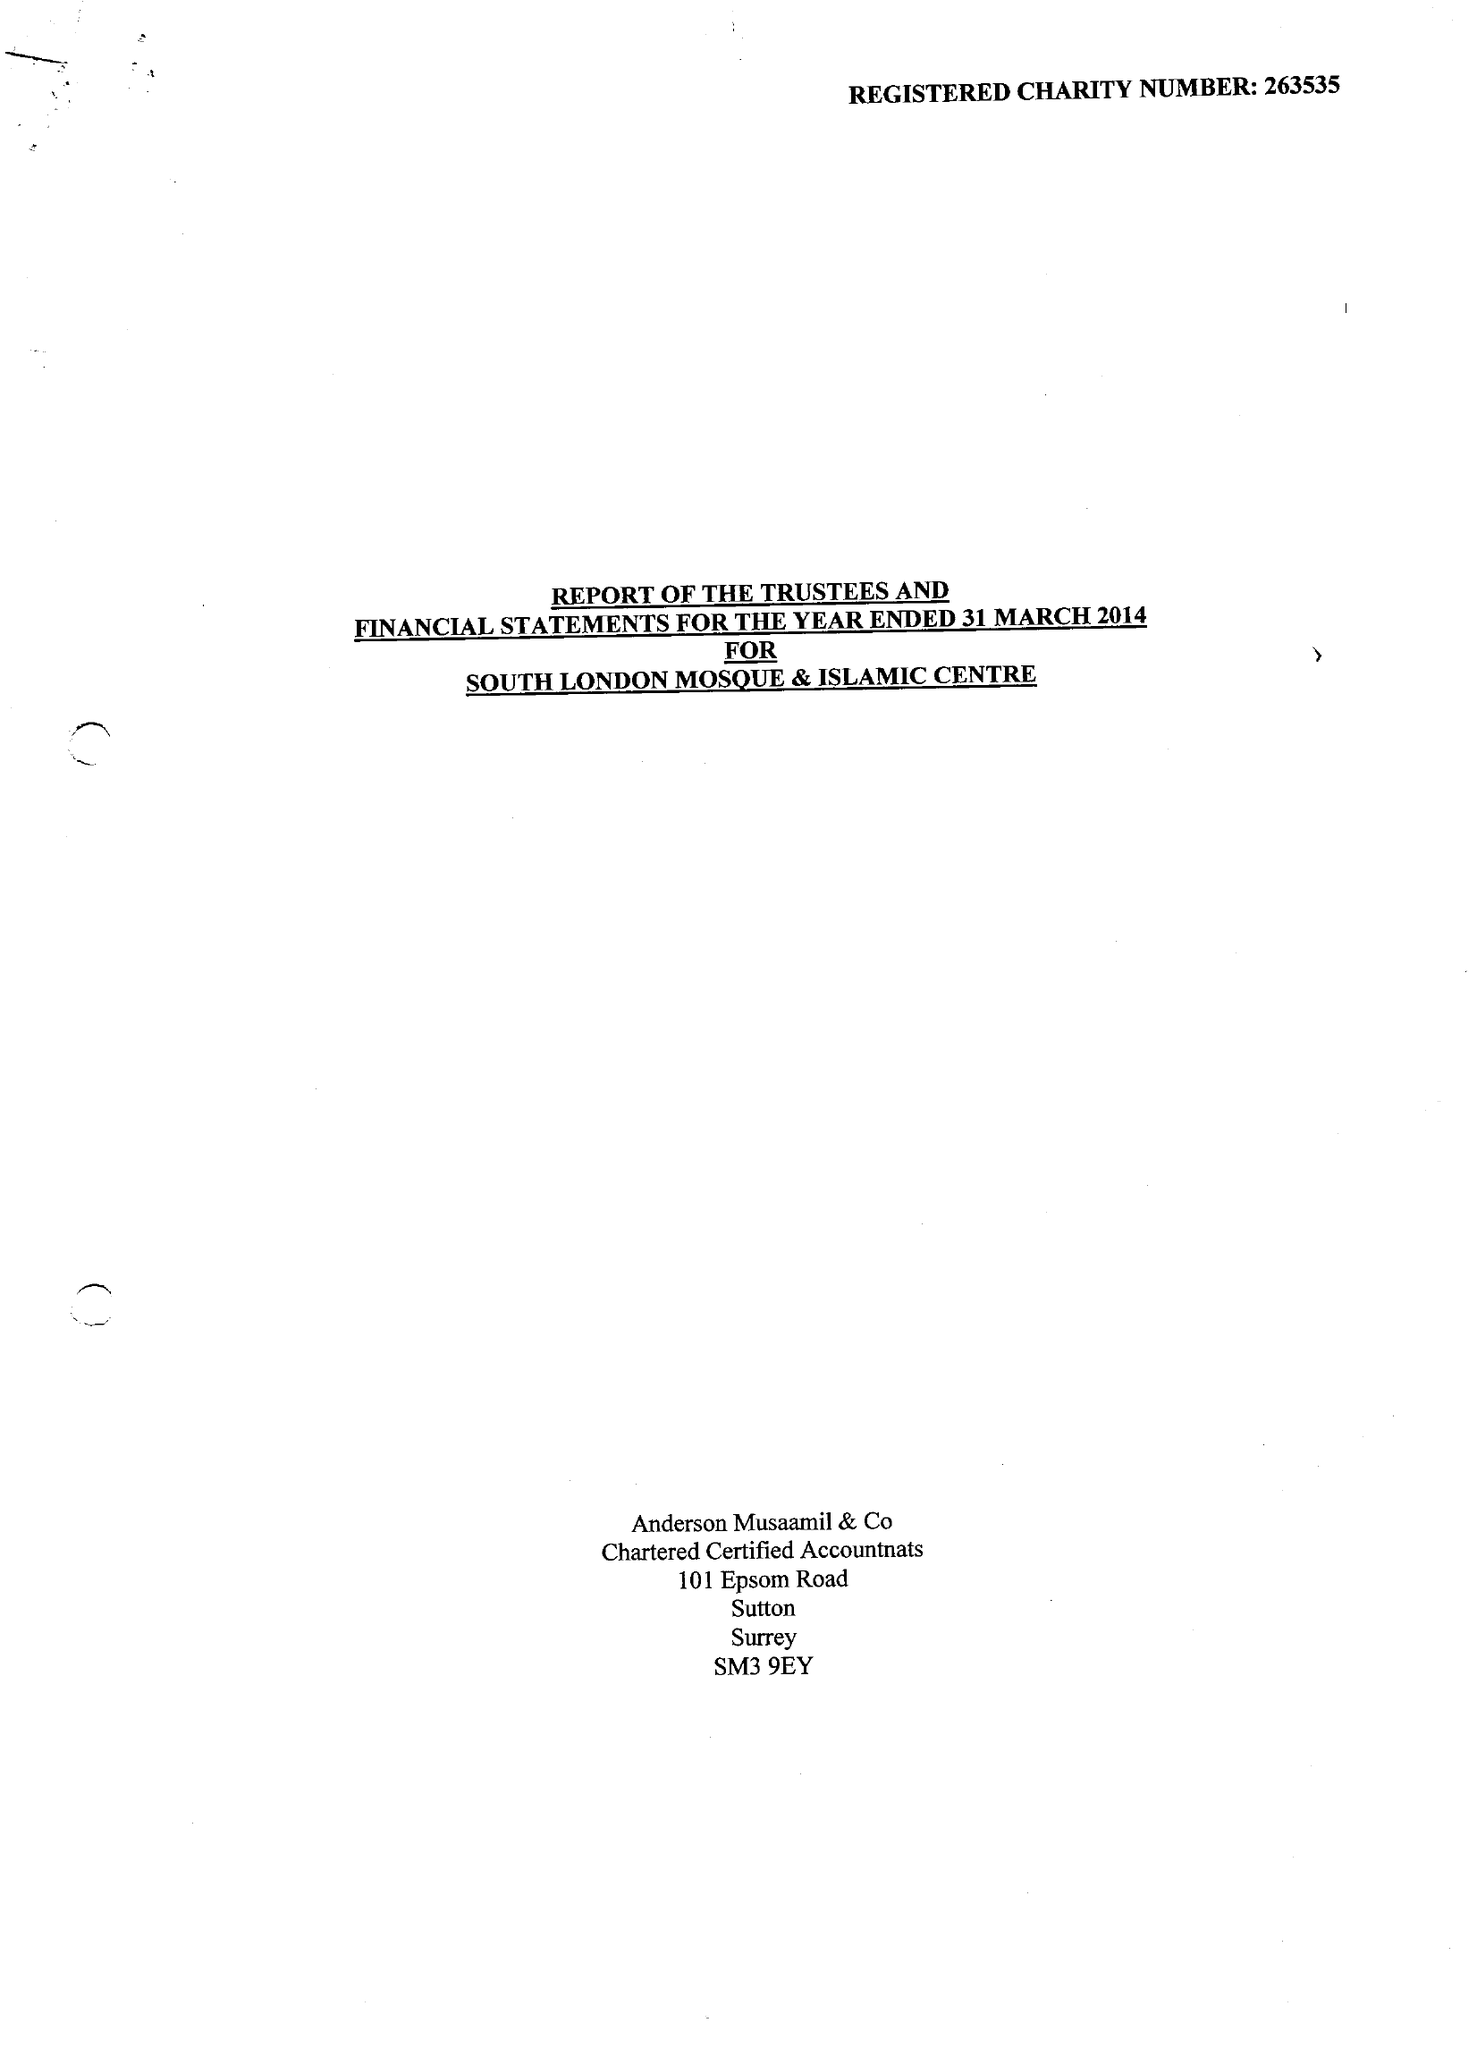What is the value for the charity_name?
Answer the question using a single word or phrase. South London Mosque and Islamic Centre 